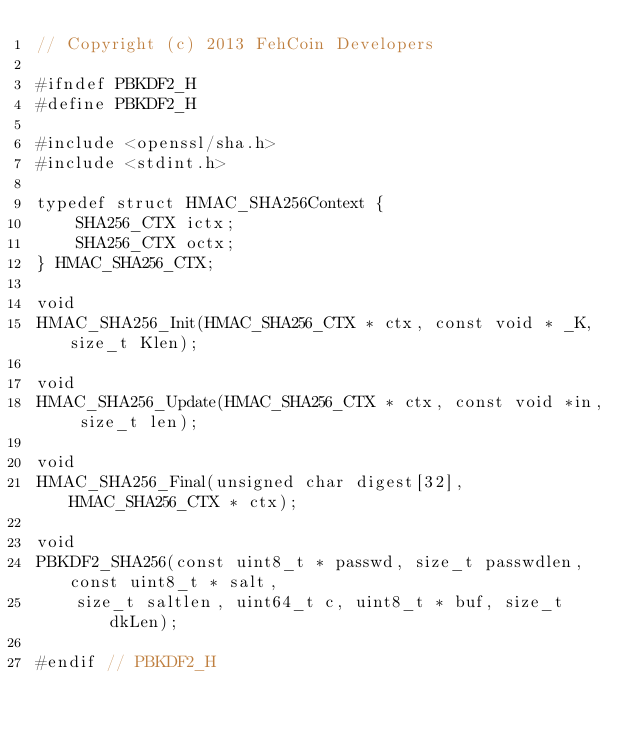Convert code to text. <code><loc_0><loc_0><loc_500><loc_500><_C_>// Copyright (c) 2013 FehCoin Developers

#ifndef PBKDF2_H
#define PBKDF2_H

#include <openssl/sha.h>
#include <stdint.h>

typedef struct HMAC_SHA256Context {
    SHA256_CTX ictx;
    SHA256_CTX octx;
} HMAC_SHA256_CTX;

void
HMAC_SHA256_Init(HMAC_SHA256_CTX * ctx, const void * _K, size_t Klen);

void
HMAC_SHA256_Update(HMAC_SHA256_CTX * ctx, const void *in, size_t len);

void
HMAC_SHA256_Final(unsigned char digest[32], HMAC_SHA256_CTX * ctx);

void
PBKDF2_SHA256(const uint8_t * passwd, size_t passwdlen, const uint8_t * salt,
    size_t saltlen, uint64_t c, uint8_t * buf, size_t dkLen);

#endif // PBKDF2_H
</code> 